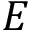Convert formula to latex. <formula><loc_0><loc_0><loc_500><loc_500>E</formula> 